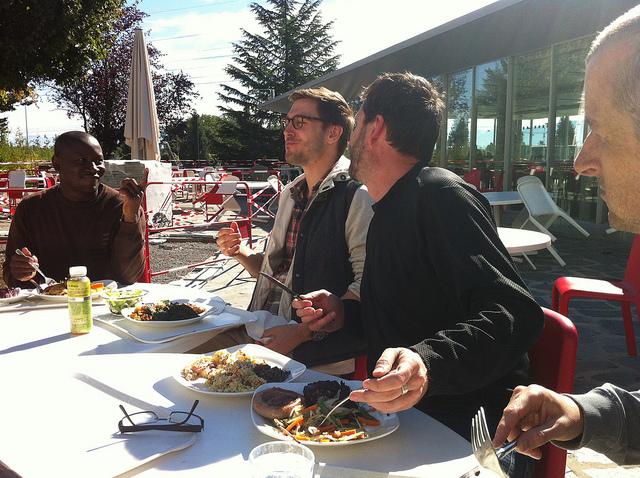How many men are in this picture?
Keep it brief. 4. Where is the balding man?
Quick response, please. Head of table. Are the people eating?
Answer briefly. Yes. 